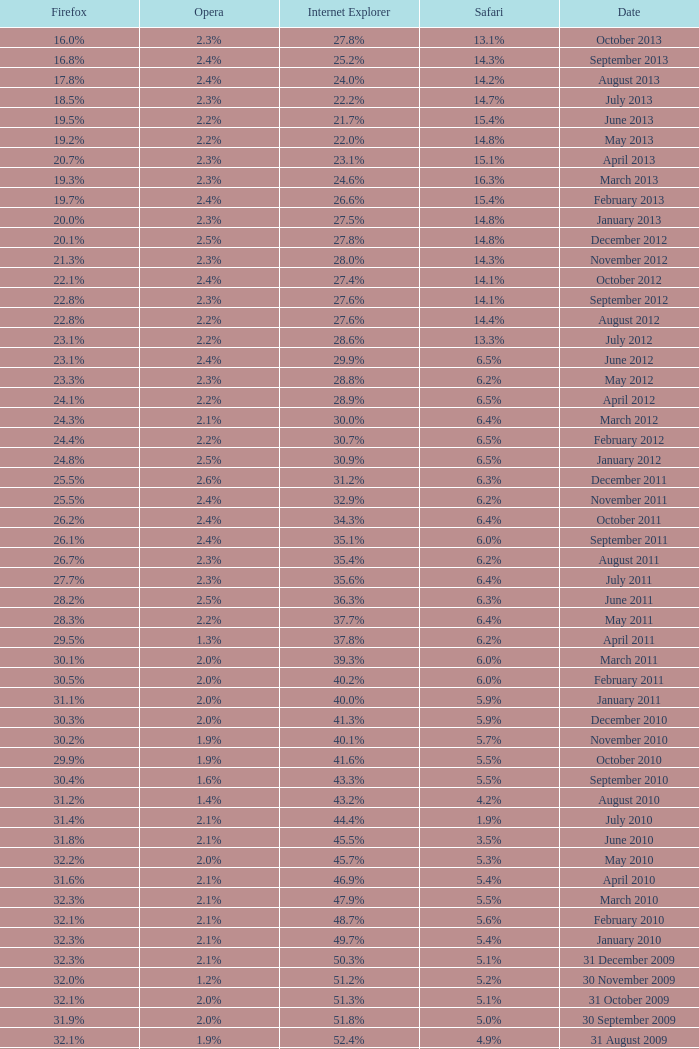What is the firefox value with a 1.9% safari? 31.4%. 